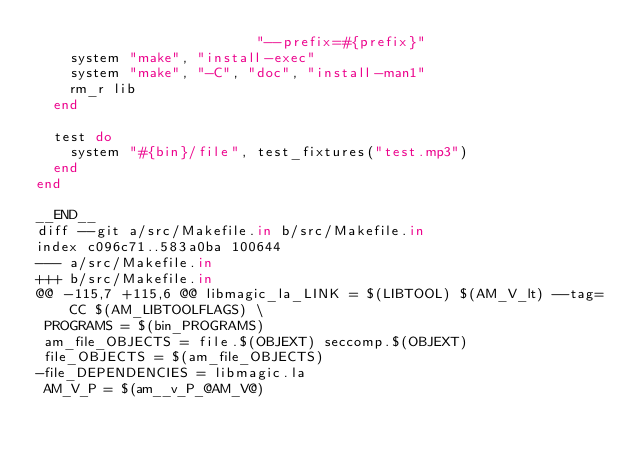<code> <loc_0><loc_0><loc_500><loc_500><_Ruby_>                          "--prefix=#{prefix}"
    system "make", "install-exec"
    system "make", "-C", "doc", "install-man1"
    rm_r lib
  end

  test do
    system "#{bin}/file", test_fixtures("test.mp3")
  end
end

__END__
diff --git a/src/Makefile.in b/src/Makefile.in
index c096c71..583a0ba 100644
--- a/src/Makefile.in
+++ b/src/Makefile.in
@@ -115,7 +115,6 @@ libmagic_la_LINK = $(LIBTOOL) $(AM_V_lt) --tag=CC $(AM_LIBTOOLFLAGS) \
 PROGRAMS = $(bin_PROGRAMS)
 am_file_OBJECTS = file.$(OBJEXT) seccomp.$(OBJEXT)
 file_OBJECTS = $(am_file_OBJECTS)
-file_DEPENDENCIES = libmagic.la
 AM_V_P = $(am__v_P_@AM_V@)</code> 